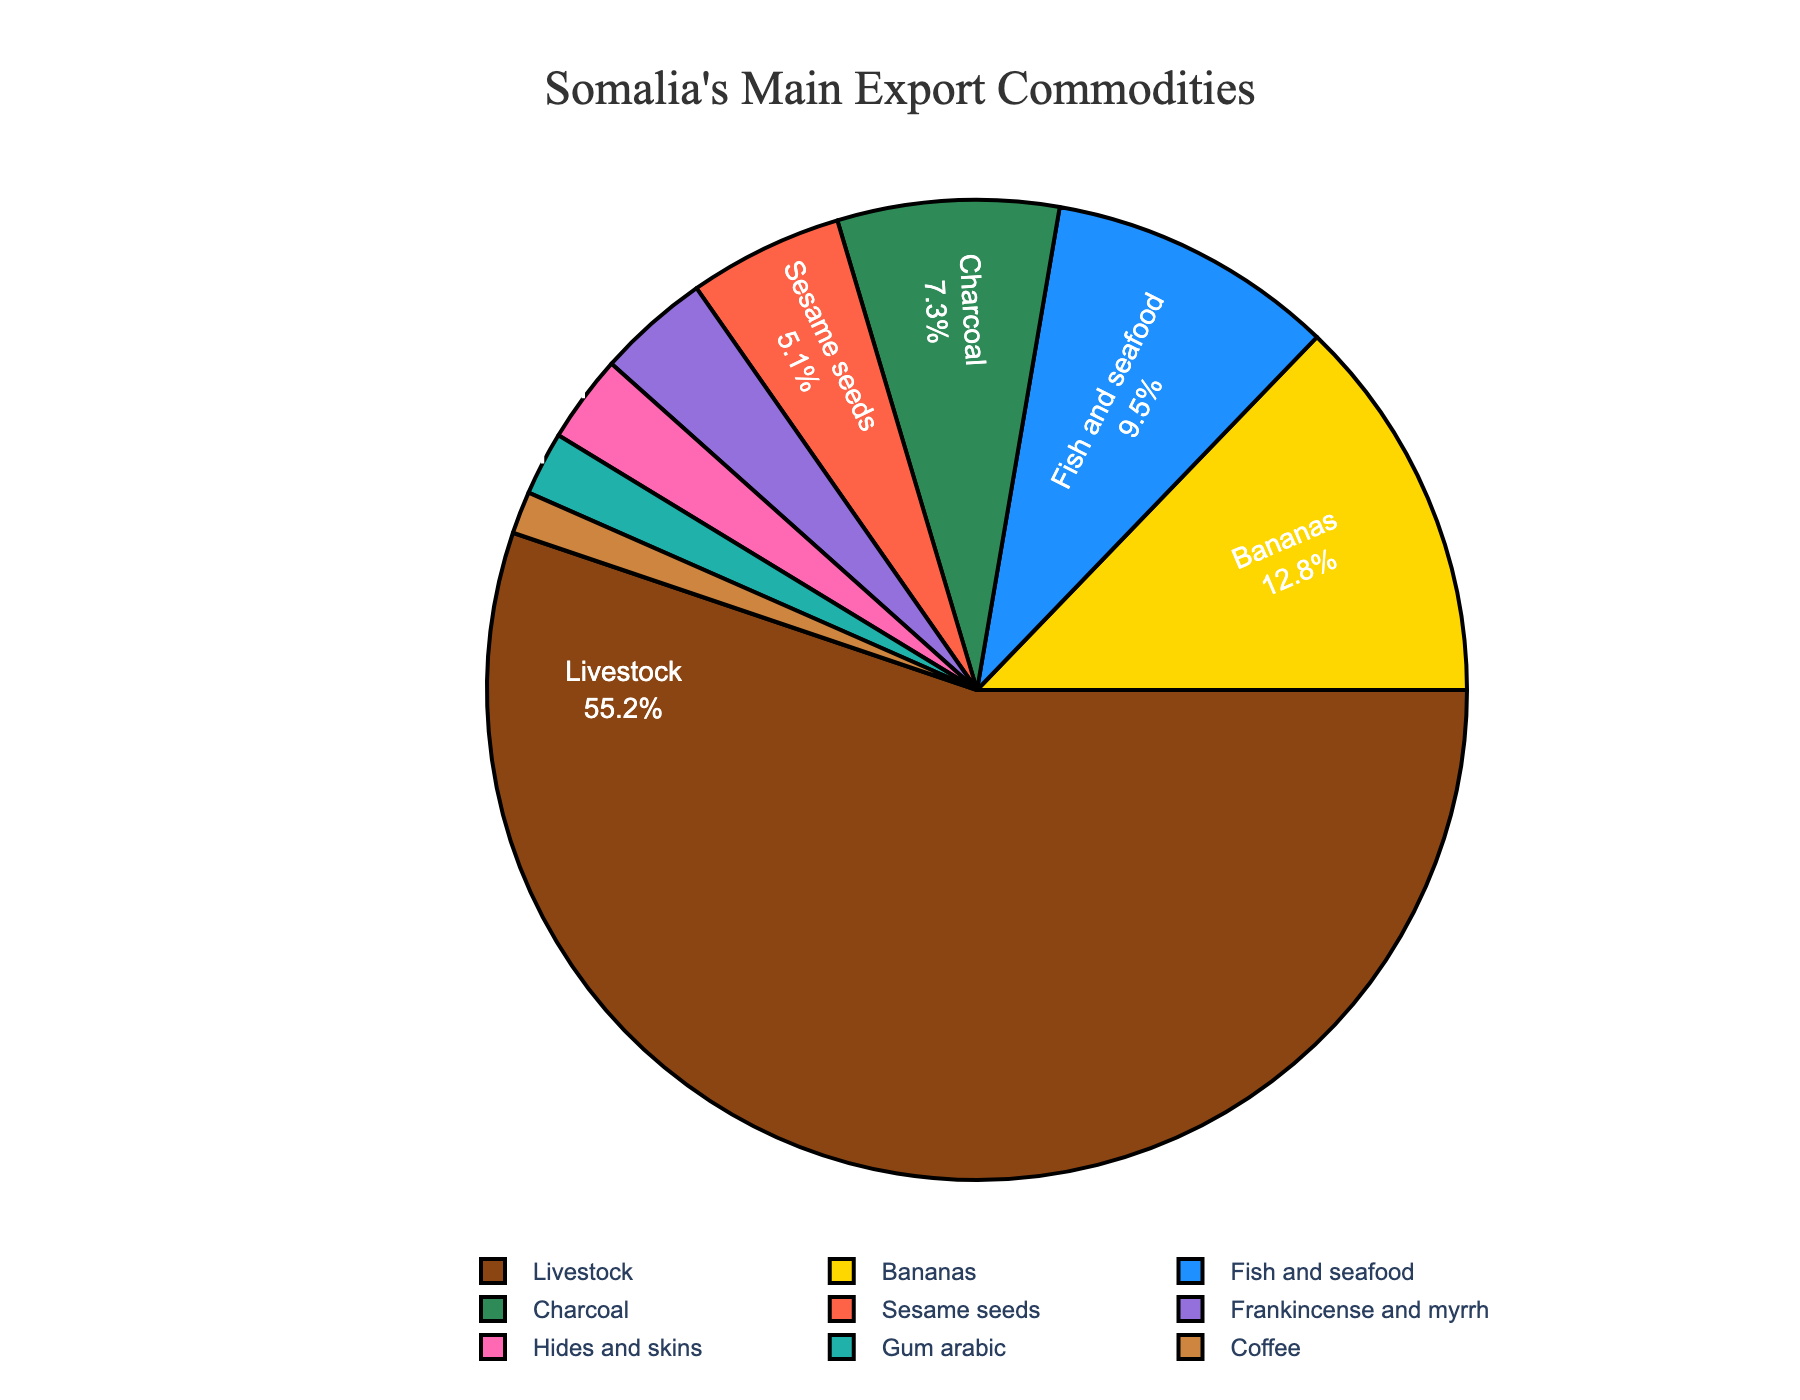Which commodity makes up the largest portion of Somalia's main export commodities? To find the commodity that makes up the largest portion of the pie chart, look for the section with the highest percentage. Livestock has the largest portion at 55.2%.
Answer: Livestock What is the total percentage of fish and seafood and hides and skins? Add the percentages of fish and seafood (9.5%) and hides and skins (2.9%). 9.5% + 2.9% = 12.4%.
Answer: 12.4% Which commodity has a higher export percentage, charcoal or bananas? Compare the percentages of charcoal (7.3%) and bananas (12.8%). Bananas have a higher percentage.
Answer: Bananas What is the combined percentage of the three least exported commodities? Add the percentages of the three least exported commodities: gum arabic (2.1%), coffee (1.4%), and hides and skins (2.9%). 2.1% + 1.4% + 2.9% = 6.4%.
Answer: 6.4% How does the percentage of livestock exports compare to the total percentage of fish and seafood, sesame seeds, and charcoal combined? Add the percentages of fish and seafood (9.5%), sesame seeds (5.1%), and charcoal (7.3%) and compare to livestock (55.2%). 9.5% + 5.1% + 7.3% = 21.9%, which is less than 55.2%.
Answer: Livestock is greater Is the export percentage of bananas more than double that of sesame seeds? Compare if the percentage of bananas (12.8%) is more than twice that of sesame seeds (5.1%). Calculate 5.1% × 2 = 10.2%, which is less than 12.8%.
Answer: Yes Which commodity is represented by the purple section of the chart? Identify the segment of the pie chart colored in purple; referring to the set colors, it represents frankincense and myrrh (3.7%).
Answer: Frankincense and myrrh What visual attribute indicates that livestock is the most exported commodity? The largest section of the pie chart visually indicates the largest export, which is colored brown and labeled 55.2%.
Answer: Largest section (brown) 